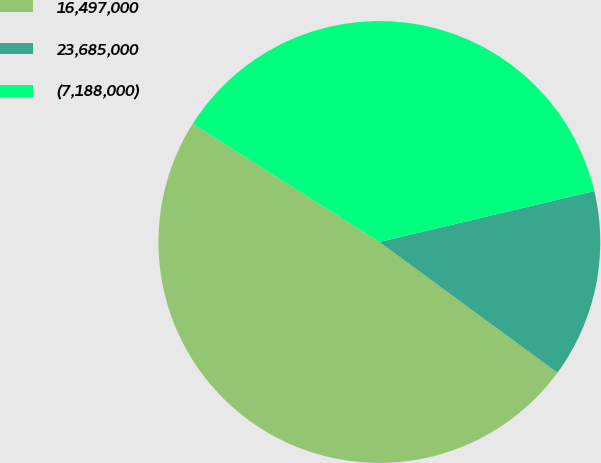Convert chart. <chart><loc_0><loc_0><loc_500><loc_500><pie_chart><fcel>16,497,000<fcel>23,685,000<fcel>(7,188,000)<nl><fcel>48.91%<fcel>13.78%<fcel>37.31%<nl></chart> 